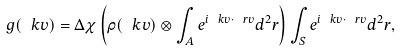Convert formula to latex. <formula><loc_0><loc_0><loc_500><loc_500>g ( \ k v ) = \Delta \chi \left ( \rho ( \ k v ) \otimes \int _ { A } e ^ { i \ k v \cdot \ r v } d ^ { 2 } r \right ) \int _ { S } e ^ { i \ k v \cdot \ r v } d ^ { 2 } r ,</formula> 